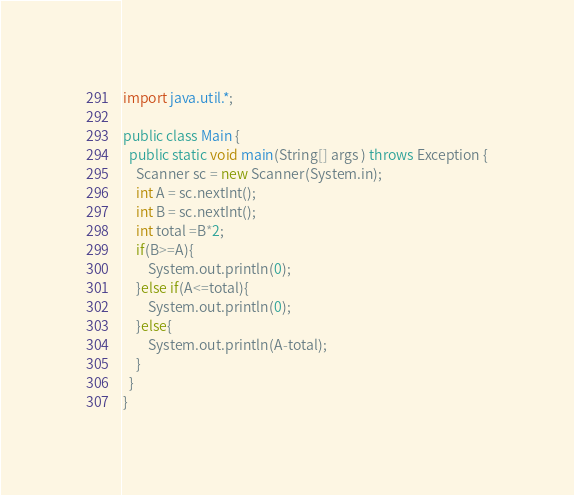<code> <loc_0><loc_0><loc_500><loc_500><_Java_>import java.util.*;

public class Main {
  public static void main(String[] args ) throws Exception {
    Scanner sc = new Scanner(System.in);
    int A = sc.nextInt();
    int B = sc.nextInt();
    int total =B*2;
    if(B>=A){
    	System.out.println(0);
    }else if(A<=total){
    	System.out.println(0);
    }else{
    	System.out.println(A-total);
    }
  }
}
</code> 